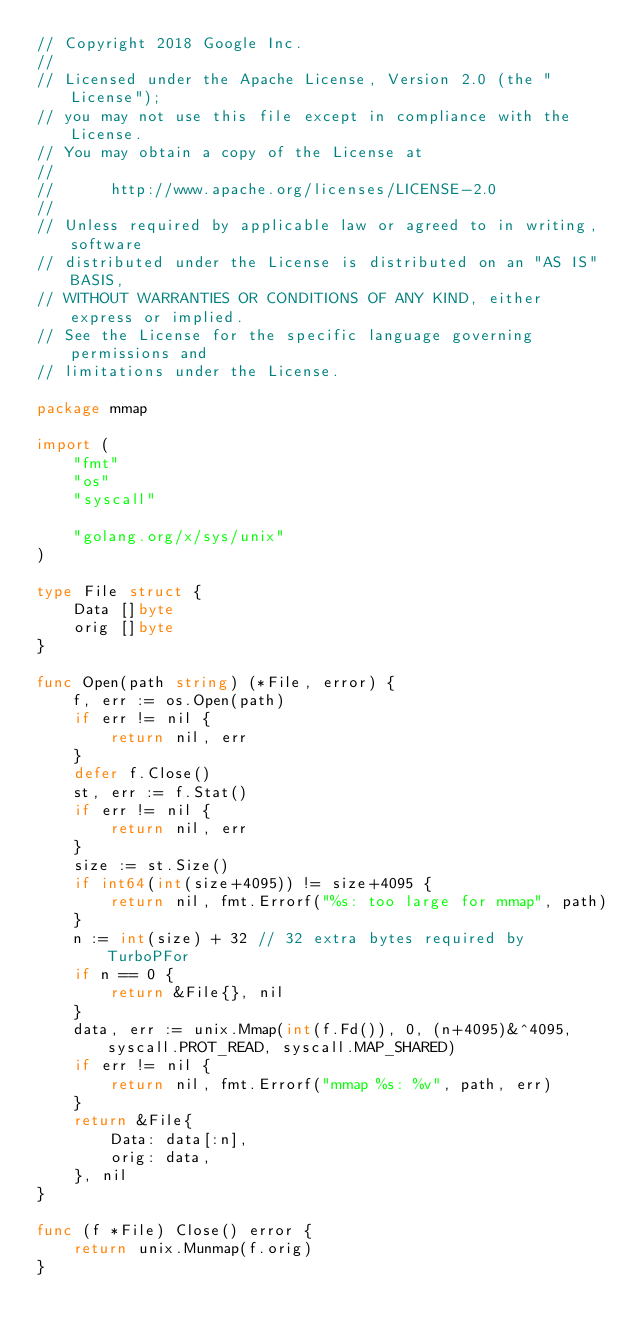<code> <loc_0><loc_0><loc_500><loc_500><_Go_>// Copyright 2018 Google Inc.
//
// Licensed under the Apache License, Version 2.0 (the "License");
// you may not use this file except in compliance with the License.
// You may obtain a copy of the License at
//
//      http://www.apache.org/licenses/LICENSE-2.0
//
// Unless required by applicable law or agreed to in writing, software
// distributed under the License is distributed on an "AS IS" BASIS,
// WITHOUT WARRANTIES OR CONDITIONS OF ANY KIND, either express or implied.
// See the License for the specific language governing permissions and
// limitations under the License.

package mmap

import (
	"fmt"
	"os"
	"syscall"

	"golang.org/x/sys/unix"
)

type File struct {
	Data []byte
	orig []byte
}

func Open(path string) (*File, error) {
	f, err := os.Open(path)
	if err != nil {
		return nil, err
	}
	defer f.Close()
	st, err := f.Stat()
	if err != nil {
		return nil, err
	}
	size := st.Size()
	if int64(int(size+4095)) != size+4095 {
		return nil, fmt.Errorf("%s: too large for mmap", path)
	}
	n := int(size) + 32 // 32 extra bytes required by TurboPFor
	if n == 0 {
		return &File{}, nil
	}
	data, err := unix.Mmap(int(f.Fd()), 0, (n+4095)&^4095, syscall.PROT_READ, syscall.MAP_SHARED)
	if err != nil {
		return nil, fmt.Errorf("mmap %s: %v", path, err)
	}
	return &File{
		Data: data[:n],
		orig: data,
	}, nil
}

func (f *File) Close() error {
	return unix.Munmap(f.orig)
}
</code> 